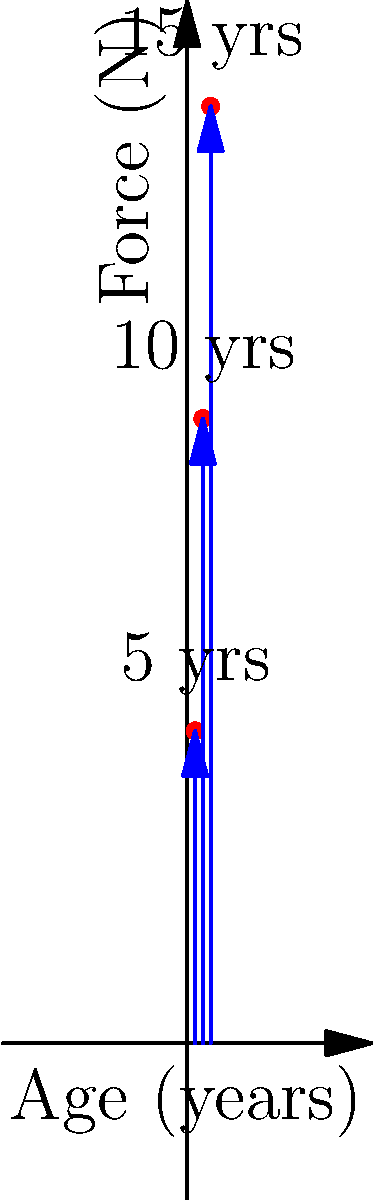Based on the force vector diagram showing the vertical ground reaction forces for children running at ages 5, 10, and 15 years, what biomechanical trend can be observed in the running patterns as children age? Explain the potential reasons for this trend. To answer this question, let's analyze the force vector diagram step-by-step:

1. Observe the vertical force vectors:
   - At 5 years: The force vector is shortest, reaching about 200 N.
   - At 10 years: The force vector is longer, reaching about 400 N.
   - At 15 years: The force vector is longest, reaching about 600 N.

2. Identify the trend:
   The vertical ground reaction force increases with age.

3. Reasons for this trend:
   a) Body mass: As children grow, their body mass increases, leading to greater force applied to the ground during running.
   
   b) Muscle strength: Older children have more developed muscles, allowing them to generate more force during the push-off phase of running.
   
   c) Stride length: With age, children typically increase their stride length, which can result in higher vertical forces due to increased vertical displacement of the center of mass.
   
   d) Running speed: Older children generally run faster, which increases the vertical ground reaction force due to higher impact velocities.
   
   e) Bone density and joint development: As the skeletal system matures, it becomes better equipped to handle and transmit larger forces.

4. Biomechanical implications:
   - The increasing force with age suggests that children's running patterns become more efficient and powerful as they develop.
   - This trend also indicates that older children may be at higher risk for impact-related injuries if proper running techniques and appropriate footwear are not used.

The observed trend shows a clear increase in vertical ground reaction forces as children age, which can be attributed to various physiological and biomechanical developments occurring during growth.
Answer: Increasing vertical ground reaction force with age due to growth, muscle development, and improved running mechanics. 